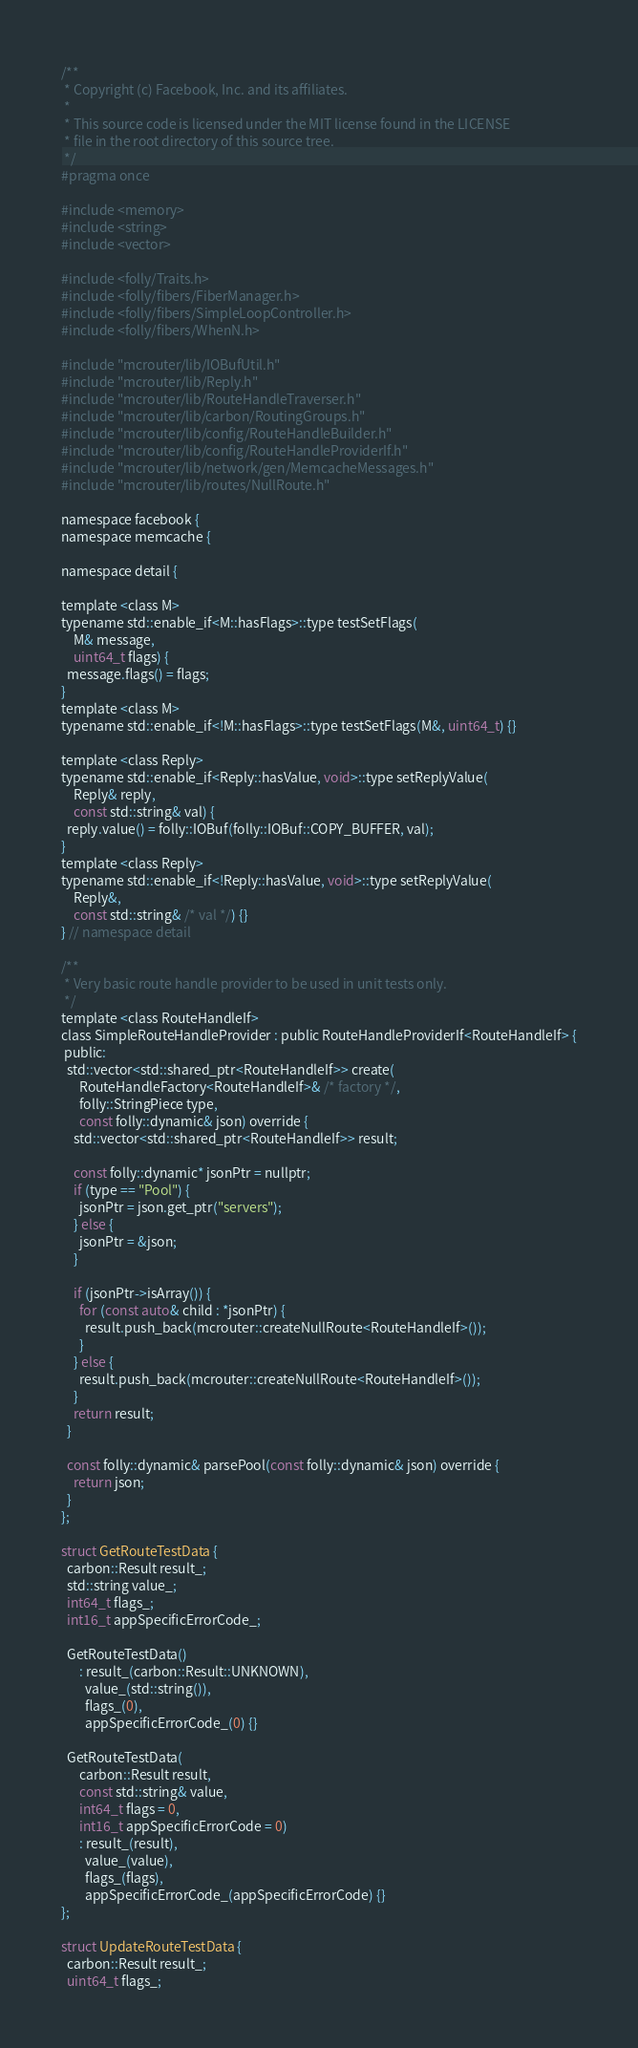<code> <loc_0><loc_0><loc_500><loc_500><_C_>/**
 * Copyright (c) Facebook, Inc. and its affiliates.
 *
 * This source code is licensed under the MIT license found in the LICENSE
 * file in the root directory of this source tree.
 */
#pragma once

#include <memory>
#include <string>
#include <vector>

#include <folly/Traits.h>
#include <folly/fibers/FiberManager.h>
#include <folly/fibers/SimpleLoopController.h>
#include <folly/fibers/WhenN.h>

#include "mcrouter/lib/IOBufUtil.h"
#include "mcrouter/lib/Reply.h"
#include "mcrouter/lib/RouteHandleTraverser.h"
#include "mcrouter/lib/carbon/RoutingGroups.h"
#include "mcrouter/lib/config/RouteHandleBuilder.h"
#include "mcrouter/lib/config/RouteHandleProviderIf.h"
#include "mcrouter/lib/network/gen/MemcacheMessages.h"
#include "mcrouter/lib/routes/NullRoute.h"

namespace facebook {
namespace memcache {

namespace detail {

template <class M>
typename std::enable_if<M::hasFlags>::type testSetFlags(
    M& message,
    uint64_t flags) {
  message.flags() = flags;
}
template <class M>
typename std::enable_if<!M::hasFlags>::type testSetFlags(M&, uint64_t) {}

template <class Reply>
typename std::enable_if<Reply::hasValue, void>::type setReplyValue(
    Reply& reply,
    const std::string& val) {
  reply.value() = folly::IOBuf(folly::IOBuf::COPY_BUFFER, val);
}
template <class Reply>
typename std::enable_if<!Reply::hasValue, void>::type setReplyValue(
    Reply&,
    const std::string& /* val */) {}
} // namespace detail

/**
 * Very basic route handle provider to be used in unit tests only.
 */
template <class RouteHandleIf>
class SimpleRouteHandleProvider : public RouteHandleProviderIf<RouteHandleIf> {
 public:
  std::vector<std::shared_ptr<RouteHandleIf>> create(
      RouteHandleFactory<RouteHandleIf>& /* factory */,
      folly::StringPiece type,
      const folly::dynamic& json) override {
    std::vector<std::shared_ptr<RouteHandleIf>> result;

    const folly::dynamic* jsonPtr = nullptr;
    if (type == "Pool") {
      jsonPtr = json.get_ptr("servers");
    } else {
      jsonPtr = &json;
    }

    if (jsonPtr->isArray()) {
      for (const auto& child : *jsonPtr) {
        result.push_back(mcrouter::createNullRoute<RouteHandleIf>());
      }
    } else {
      result.push_back(mcrouter::createNullRoute<RouteHandleIf>());
    }
    return result;
  }

  const folly::dynamic& parsePool(const folly::dynamic& json) override {
    return json;
  }
};

struct GetRouteTestData {
  carbon::Result result_;
  std::string value_;
  int64_t flags_;
  int16_t appSpecificErrorCode_;

  GetRouteTestData()
      : result_(carbon::Result::UNKNOWN),
        value_(std::string()),
        flags_(0),
        appSpecificErrorCode_(0) {}

  GetRouteTestData(
      carbon::Result result,
      const std::string& value,
      int64_t flags = 0,
      int16_t appSpecificErrorCode = 0)
      : result_(result),
        value_(value),
        flags_(flags),
        appSpecificErrorCode_(appSpecificErrorCode) {}
};

struct UpdateRouteTestData {
  carbon::Result result_;
  uint64_t flags_;
</code> 